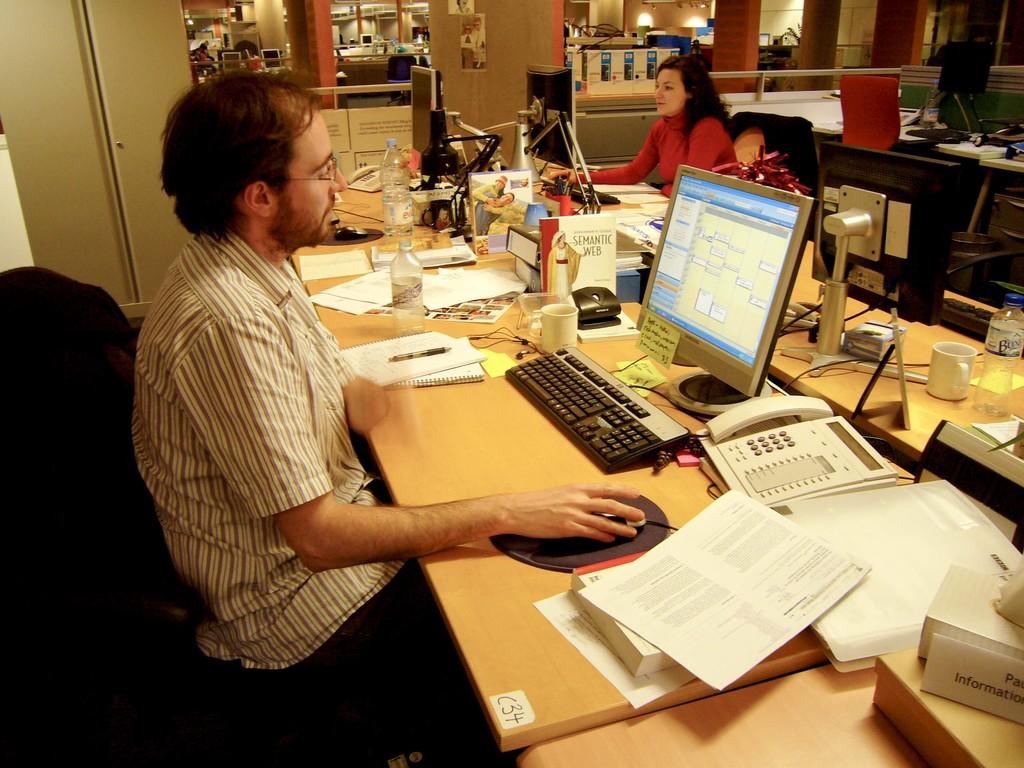What is the title of the book on the man's desk?
Your response must be concise. Semantic web. What are the numbers on the right corner of the table?
Ensure brevity in your answer.  34. 